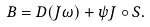Convert formula to latex. <formula><loc_0><loc_0><loc_500><loc_500>B = D ( J \omega ) + \psi J \circ S .</formula> 